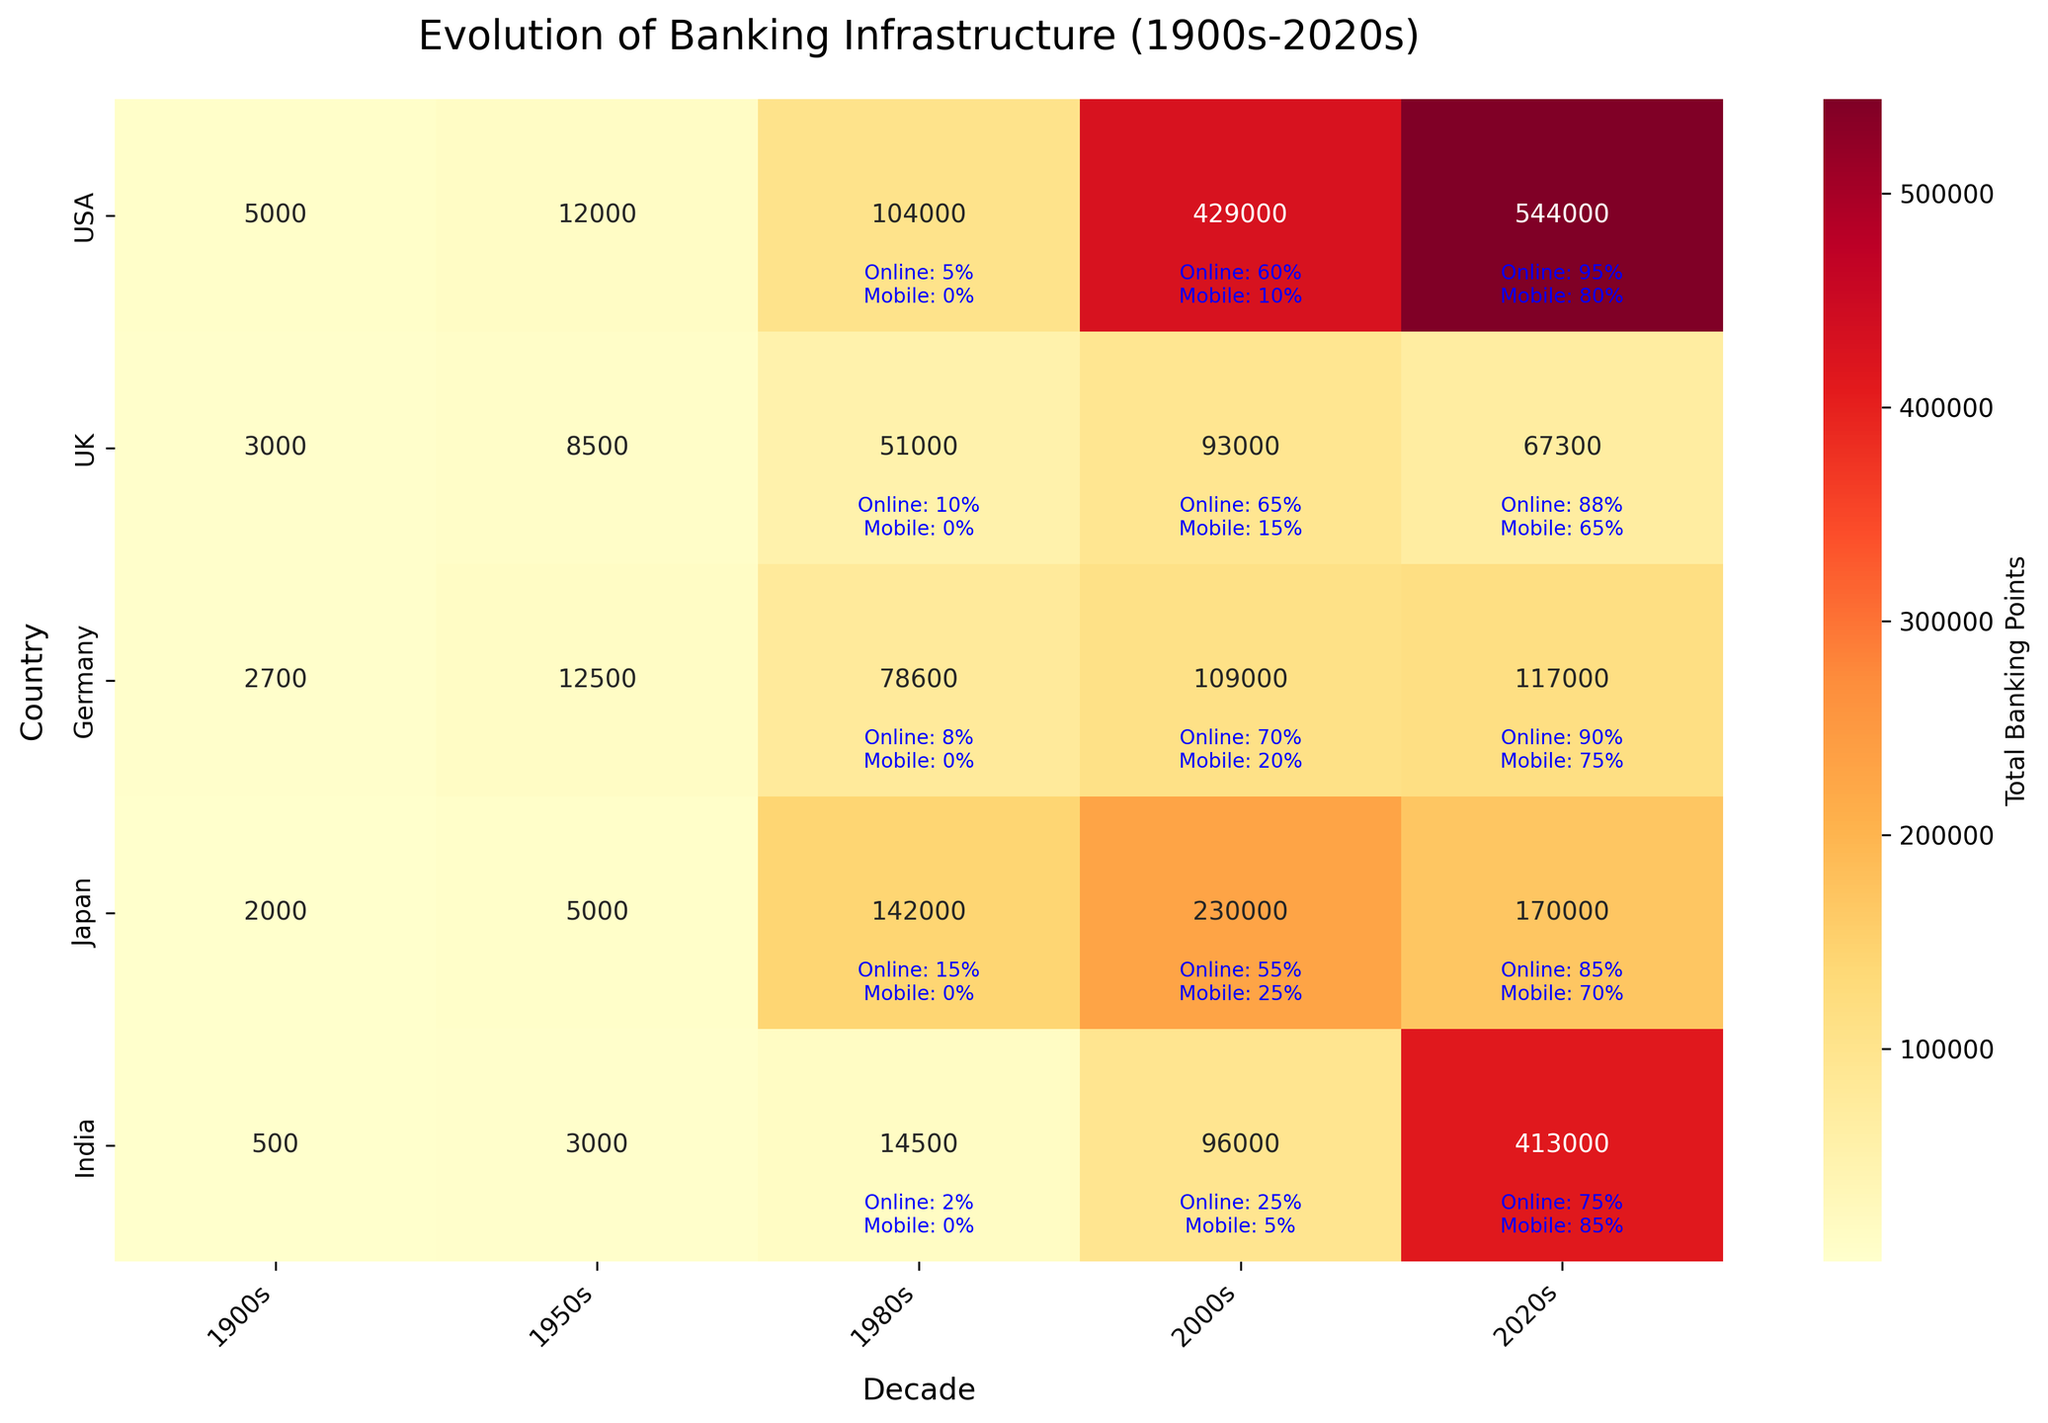What is the title of the heatmap? The title of the heatmap is displayed at the top of the plot, it indicates the main topic or focus of the visualization.
Answer: Evolution of Banking Infrastructure (1900s-2020s) Which country had the highest number of total banking points in the 2020s? By observing the heatmap, the country with the highest value in the 2020s column is India.
Answer: India How many bank branches and ATMs did the USA have in the 2000s combined? The heatmap shows total banking points for each country and decade where the USA in the 2000s has a value of 352,000 (bank branches) + 470,000 (ATMs) = 442,000.
Answer: 442,000 Compare the number of banking points in Japan in the 1950s and 1980s. Which decade had a higher count? Observe the heatmap to compare the values in the columns for 1950s and 1980s for Japan. We see Japan had more total banking points in the 1980s.
Answer: 1980s Which decade had marked the highest growth in online banking adoption in India? We look at the annotations for online banking adoption in the India row and compare the values across decades to see the highest growth by percentage increase, particularly from the 2000s (25%) to the 2020s (75%).
Answer: 2020s What color is primarily used to indicate high values in the heatmap? The heatmap uses a color gradient to indicate values, with higher values represented by warmer colors.
Answer: Red Which country had a decrease in the number of total banking points from the 2000s to the 2020s? By comparing the values in the heatmap for the 2000s and 2020s columns, the UK and Japan had a decrease in total banking points.
Answer: UK and Japan Explain the difference in mobile banking adoption between Germany and India in the 2020s. Examine the heatmap annotations for mobile banking adoption in Germany and India in the 2020s to compare 75% (Germany) and 85% (India). The difference is 85% - 75% = 10%.
Answer: 10% What was the overall trend for the total number of banking points in the USA from the 1900s to the 2020s? Observe the heatmap values for the USA across all columns, seeing an initial increase followed by a slight decrease in the 2020s.
Answer: Increasing, then slight decrease 